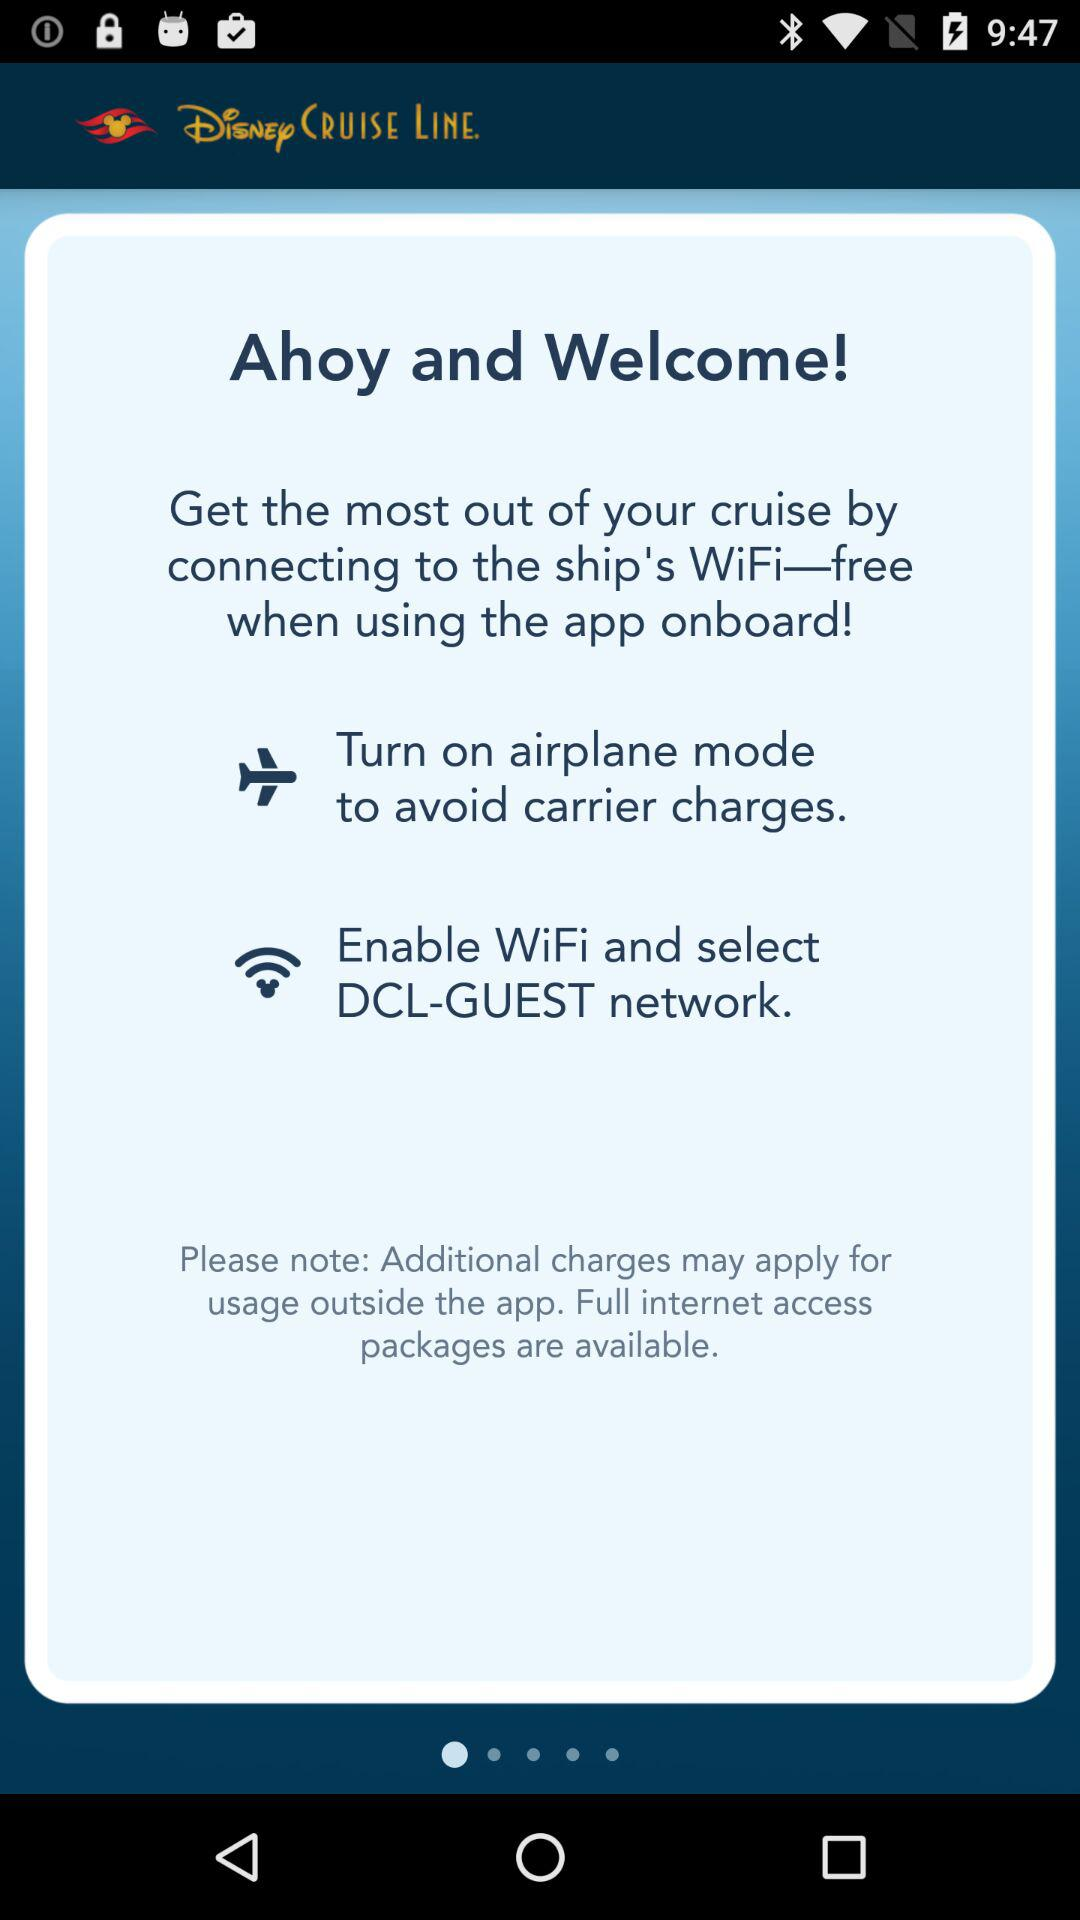What is the WiFi password for "DCL-GUEST"?
When the provided information is insufficient, respond with <no answer>. <no answer> 